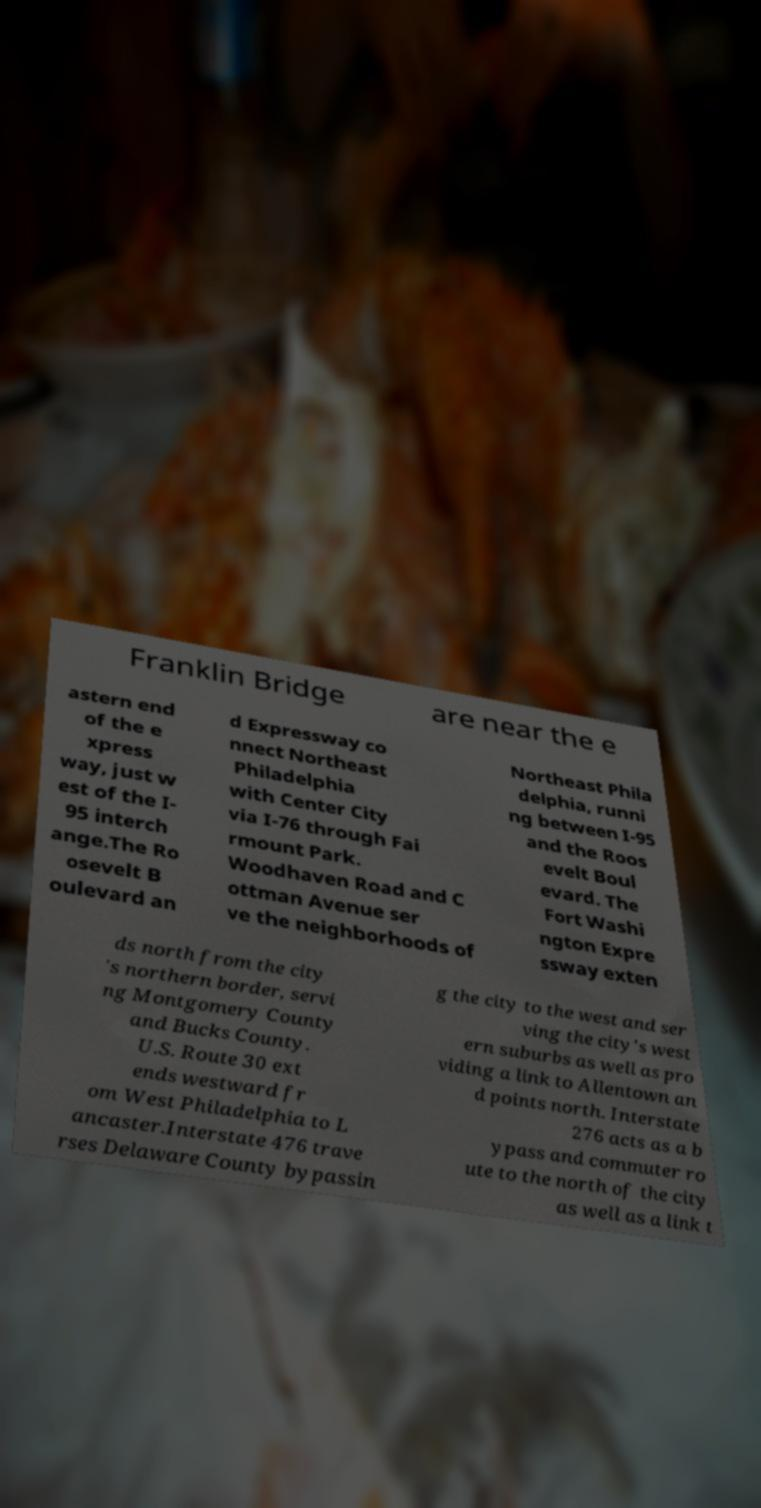There's text embedded in this image that I need extracted. Can you transcribe it verbatim? Franklin Bridge are near the e astern end of the e xpress way, just w est of the I- 95 interch ange.The Ro osevelt B oulevard an d Expressway co nnect Northeast Philadelphia with Center City via I-76 through Fai rmount Park. Woodhaven Road and C ottman Avenue ser ve the neighborhoods of Northeast Phila delphia, runni ng between I-95 and the Roos evelt Boul evard. The Fort Washi ngton Expre ssway exten ds north from the city 's northern border, servi ng Montgomery County and Bucks County. U.S. Route 30 ext ends westward fr om West Philadelphia to L ancaster.Interstate 476 trave rses Delaware County bypassin g the city to the west and ser ving the city's west ern suburbs as well as pro viding a link to Allentown an d points north. Interstate 276 acts as a b ypass and commuter ro ute to the north of the city as well as a link t 